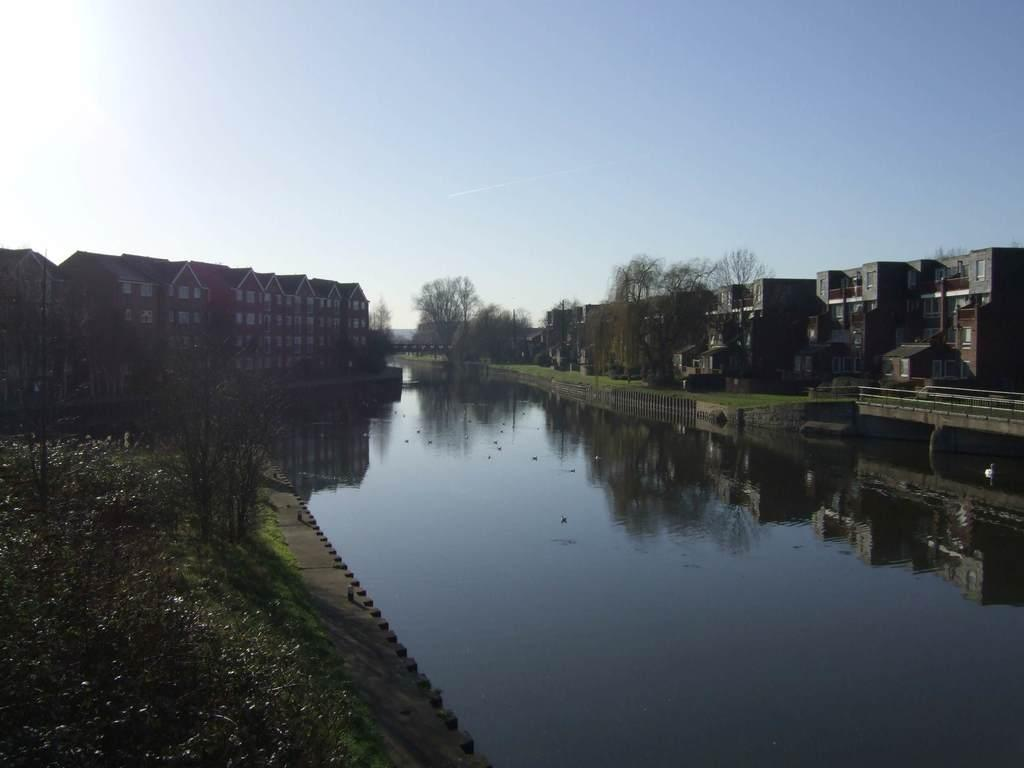What is the main feature in the center of the image? There is a lake in the center of the image. What can be seen in the background of the image? There are trees and buildings in the background of the image. What is visible at the top of the image? The sky is visible at the top of the image. What type of fear can be seen on the doll's face in the image? There is no doll present in the image, so it is not possible to determine if there is any fear on its face. 